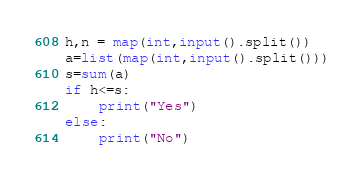<code> <loc_0><loc_0><loc_500><loc_500><_Python_>h,n = map(int,input().split())
a=list(map(int,input().split()))
s=sum(a)
if h<=s:
    print("Yes")
else:
    print("No")</code> 